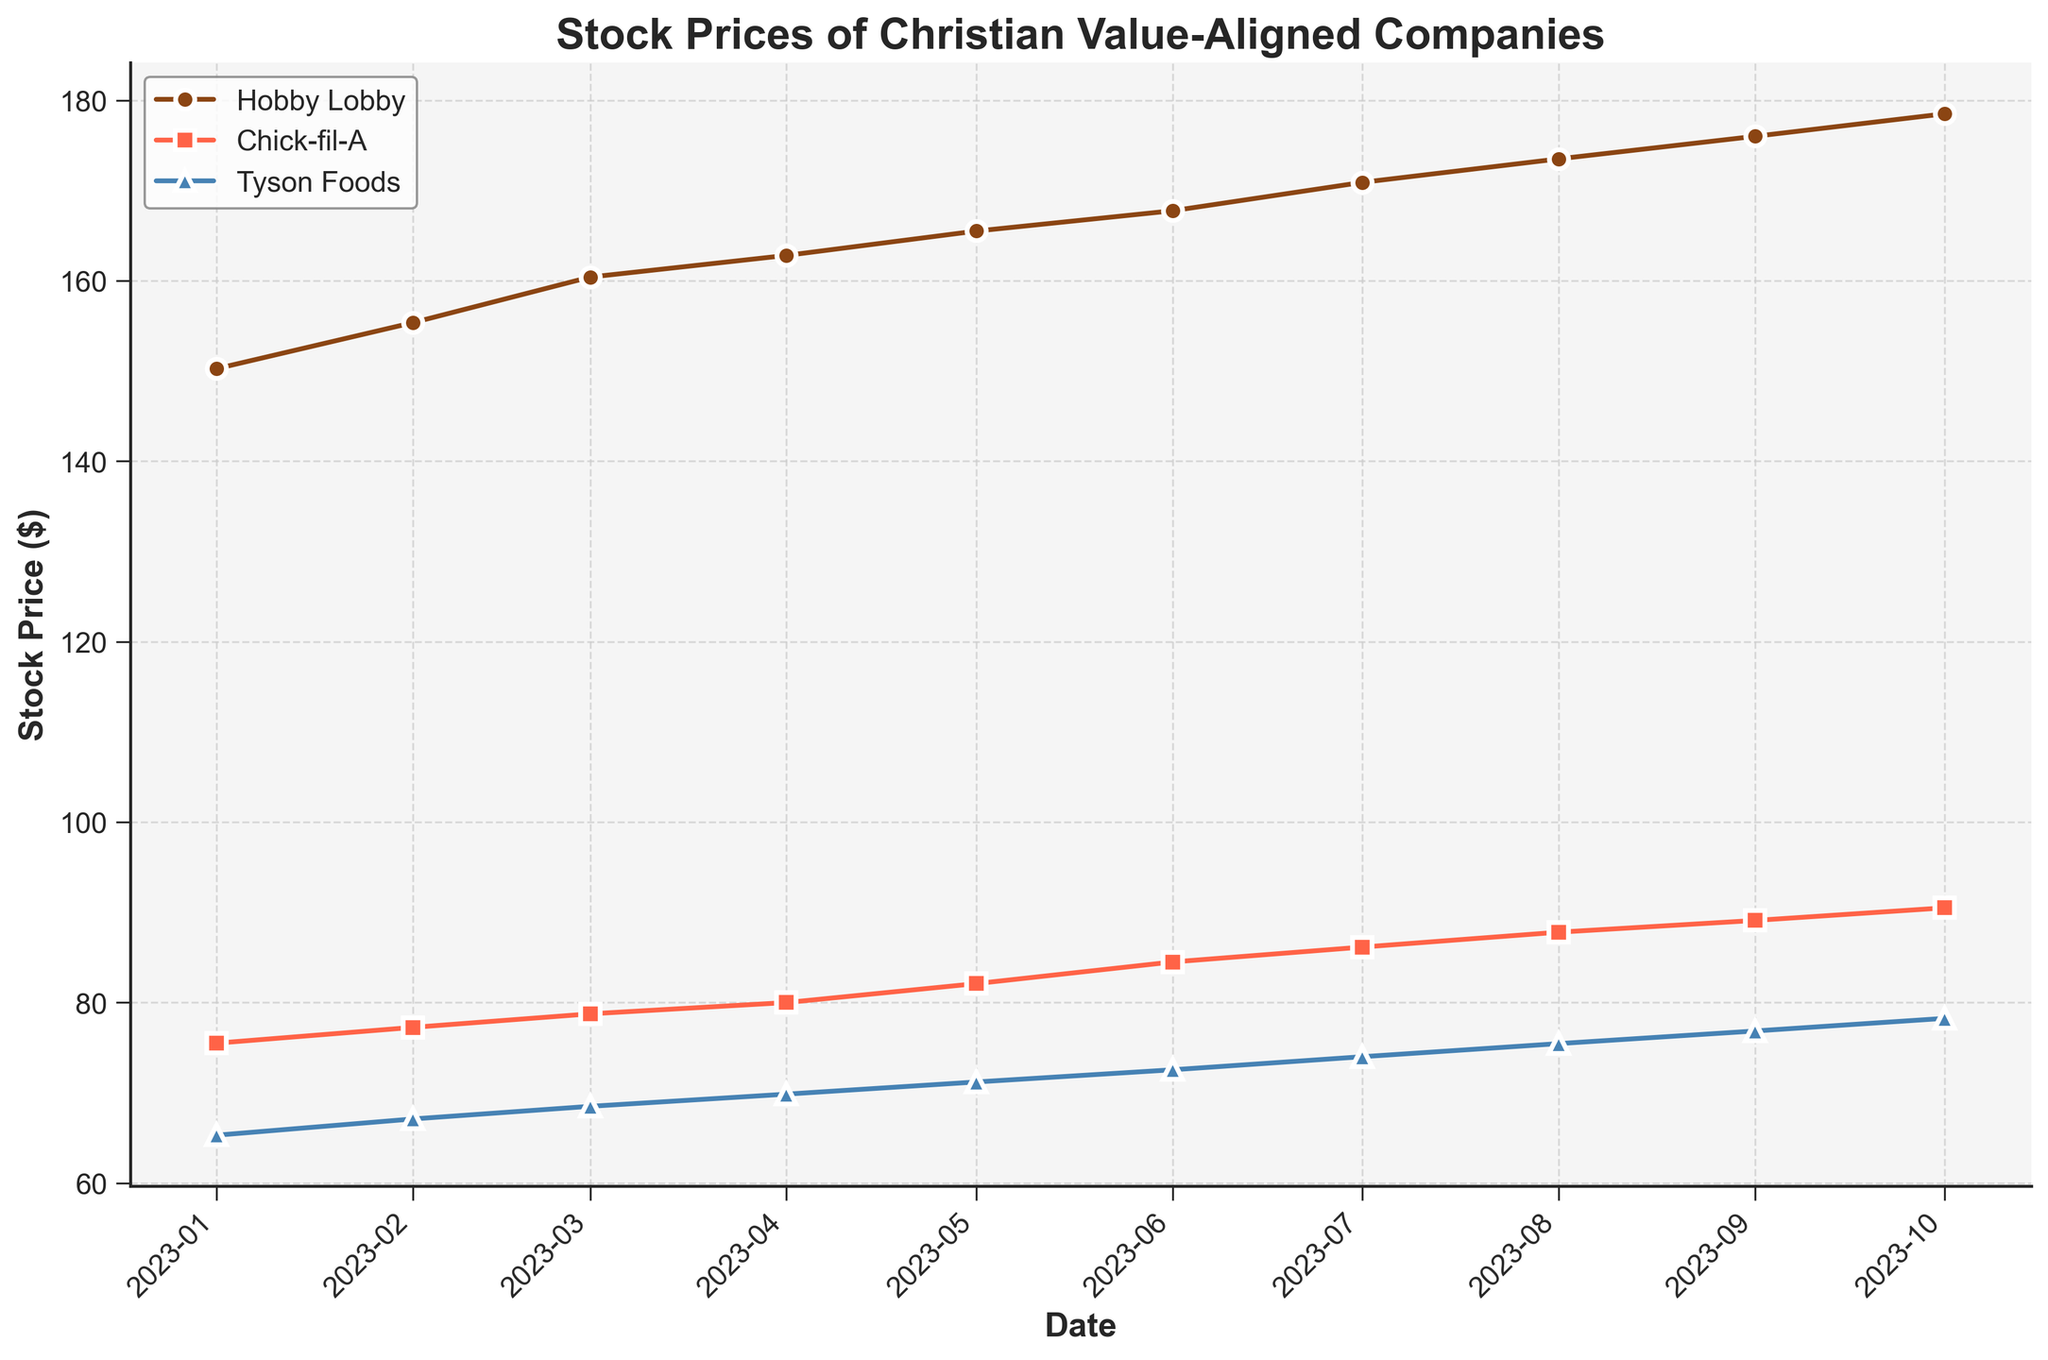What is the title of the plot? The title of the plot is located at the top and is described in the code as 'Stock Prices of Christian Value-Aligned Companies'.
Answer: Stock Prices of Christian Value-Aligned Companies What are the companies shown in the plot? The legend in the plot provides the names of the companies. They are Hobby Lobby, Chick-fil-A, and Tyson Foods.
Answer: Hobby Lobby, Chick-fil-A, Tyson Foods What colors represent each company in the plot? The colors can be observed from the plot lines and the legend. Hobby Lobby is represented by brown, Chick-fil-A by red, and Tyson Foods by blue.
Answer: Hobby Lobby: brown, Chick-fil-A: red, Tyson Foods: blue On which date does Chick-fil-A have a stock price of approximately 90.50? By locating the intersection of Chick-fil-A's data points with the value 90.50 on the vertical axis (Stock Price), it matches the date category on the horizontal axis.
Answer: 2023-10-01 Between January and October 2023, which company shows the highest increase in stock price? By comparing the initial and final stock prices of all companies from January to October, it is evident that Hobby Lobby has the highest increase (178.50 - 150.25 = 28.25).
Answer: Hobby Lobby What was Tyson Foods' stock price in July 2023? Tyson Foods' stock price can be found by following the July marker on the horizontal axis and observing the value corresponding to Tyson Foods' line.
Answer: 74.00 Which month shows the peak stock price for Chick-fil-A, according to the plot? The peak value for Chick-fil-A can be found by scanning the graph for the highest data point on Chick-fil-A's line.
Answer: October 2023 What’s the average stock price of Hobby Lobby over the dataset period? Adding up all Hobby Lobby stock prices and dividing by the number of data points: (150.25+155.35+160.40+162.80+165.50+167.75+170.90+173.50+176.00+178.50) / 10.
Answer: 166.70 Which company had the lowest stock price in January 2023? By referring to the January 2023 data points and comparing them, Chick-fil-A had the lowest stock price of 75.50.
Answer: Chick-fil-A 